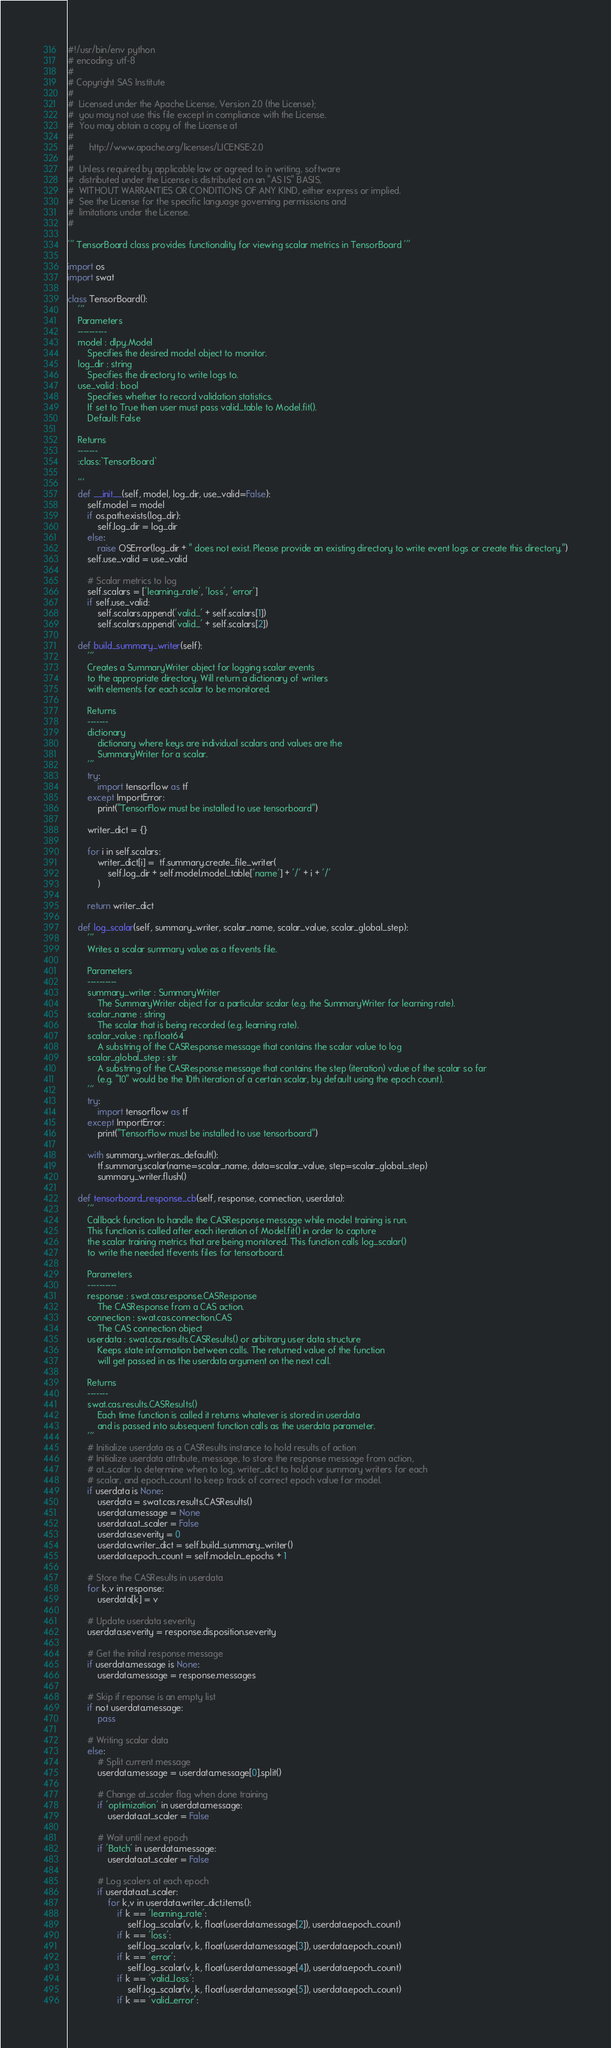<code> <loc_0><loc_0><loc_500><loc_500><_Python_>#!/usr/bin/env python
# encoding: utf-8
#
# Copyright SAS Institute
#
#  Licensed under the Apache License, Version 2.0 (the License);
#  you may not use this file except in compliance with the License.
#  You may obtain a copy of the License at
#
#      http://www.apache.org/licenses/LICENSE-2.0
#
#  Unless required by applicable law or agreed to in writing, software
#  distributed under the License is distributed on an "AS IS" BASIS,
#  WITHOUT WARRANTIES OR CONDITIONS OF ANY KIND, either express or implied.
#  See the License for the specific language governing permissions and
#  limitations under the License.
#

''' TensorBoard class provides functionality for viewing scalar metrics in TensorBoard '''

import os
import swat

class TensorBoard():
    '''
    Parameters
    ----------
    model : dlpy.Model
        Specifies the desired model object to monitor.
    log_dir : string
        Specifies the directory to write logs to.
    use_valid : bool
        Specifies whether to record validation statistics.
        If set to True then user must pass valid_table to Model.fit().
        Default: False

    Returns
    -------
    :class:`TensorBoard`

    '''
    def __init__(self, model, log_dir, use_valid=False):
        self.model = model
        if os.path.exists(log_dir):
            self.log_dir = log_dir
        else:
            raise OSError(log_dir + " does not exist. Please provide an existing directory to write event logs or create this directory.")
        self.use_valid = use_valid

        # Scalar metrics to log
        self.scalars = ['learning_rate', 'loss', 'error']
        if self.use_valid:
            self.scalars.append('valid_' + self.scalars[1])
            self.scalars.append('valid_' + self.scalars[2])

    def build_summary_writer(self):
        '''
        Creates a SummaryWriter object for logging scalar events 
        to the appropriate directory. Will return a dictionary of writers
        with elements for each scalar to be monitored.

        Returns
        -------
        dictionary
            dictionary where keys are individual scalars and values are the 
            SummaryWriter for a scalar.
        '''
        try:
            import tensorflow as tf
        except ImportError:
            print("TensorFlow must be installed to use tensorboard")

        writer_dict = {}

        for i in self.scalars:
            writer_dict[i] =  tf.summary.create_file_writer(
                self.log_dir + self.model.model_table['name'] + '/' + i + '/'
            )
                
        return writer_dict

    def log_scalar(self, summary_writer, scalar_name, scalar_value, scalar_global_step):
        '''
        Writes a scalar summary value as a tfevents file.

        Parameters
        ----------
        summary_writer : SummaryWriter
            The SummaryWriter object for a particular scalar (e.g. the SummaryWriter for learning rate).
        scalar_name : string
            The scalar that is being recorded (e.g. learning rate).
        scalar_value : np.float64
            A substring of the CASResponse message that contains the scalar value to log
        scalar_global_step : str
            A substring of the CASResponse message that contains the step (iteration) value of the scalar so far
            (e.g. "10" would be the 10th iteration of a certain scalar, by default using the epoch count).
        '''
        try:
            import tensorflow as tf
        except ImportError:
            print("TensorFlow must be installed to use tensorboard")
            
        with summary_writer.as_default():
            tf.summary.scalar(name=scalar_name, data=scalar_value, step=scalar_global_step)
            summary_writer.flush()

    def tensorboard_response_cb(self, response, connection, userdata):
        '''
        Callback function to handle the CASResponse message while model training is run. 
        This function is called after each iteration of Model.fit() in order to capture 
        the scalar training metrics that are being monitored. This function calls log_scalar() 
        to write the needed tfevents files for tensorboard.

        Parameters
        ----------
        response : swat.cas.response.CASResponse
            The CASResponse from a CAS action. 
        connection : swat.cas.connection.CAS
            The CAS connection object
        userdata : swat.cas.results.CASResults() or arbitrary user data structure
            Keeps state information between calls. The returned value of the function
            will get passed in as the userdata argument on the next call.

        Returns
        -------
        swat.cas.results.CASResults()
            Each time function is called it returns whatever is stored in userdata
            and is passed into subsequent function calls as the userdata parameter.
        '''
        # Initialize userdata as a CASResults instance to hold results of action 
        # Initialize userdata attribute, message, to store the response message from action,
        # at_scalar to determine when to log, writer_dict to hold our summary writers for each
        # scalar, and epoch_count to keep track of correct epoch value for model.
        if userdata is None:
            userdata = swat.cas.results.CASResults()
            userdata.message = None
            userdata.at_scaler = False
            userdata.severity = 0
            userdata.writer_dict = self.build_summary_writer()
            userdata.epoch_count = self.model.n_epochs + 1
            
        # Store the CASResults in userdata
        for k,v in response:
            userdata[k] = v

        # Update userdata severity 
        userdata.severity = response.disposition.severity

        # Get the initial response message
        if userdata.message is None:
            userdata.message = response.messages
            
        # Skip if reponse is an empty list
        if not userdata.message:
            pass
        
        # Writing scalar data
        else:
            # Split current message
            userdata.message = userdata.message[0].split()

            # Change at_scaler flag when done training
            if 'optimization' in userdata.message:
                userdata.at_scaler = False

            # Wait until next epoch
            if 'Batch' in userdata.message:
                userdata.at_scaler = False
            
            # Log scalers at each epoch
            if userdata.at_scaler:
                for k,v in userdata.writer_dict.items():
                    if k == 'learning_rate':
                        self.log_scalar(v, k, float(userdata.message[2]), userdata.epoch_count)
                    if k == 'loss':
                        self.log_scalar(v, k, float(userdata.message[3]), userdata.epoch_count)
                    if k == 'error':
                        self.log_scalar(v, k, float(userdata.message[4]), userdata.epoch_count)
                    if k == 'valid_loss':
                        self.log_scalar(v, k, float(userdata.message[5]), userdata.epoch_count)
                    if k == 'valid_error':</code> 